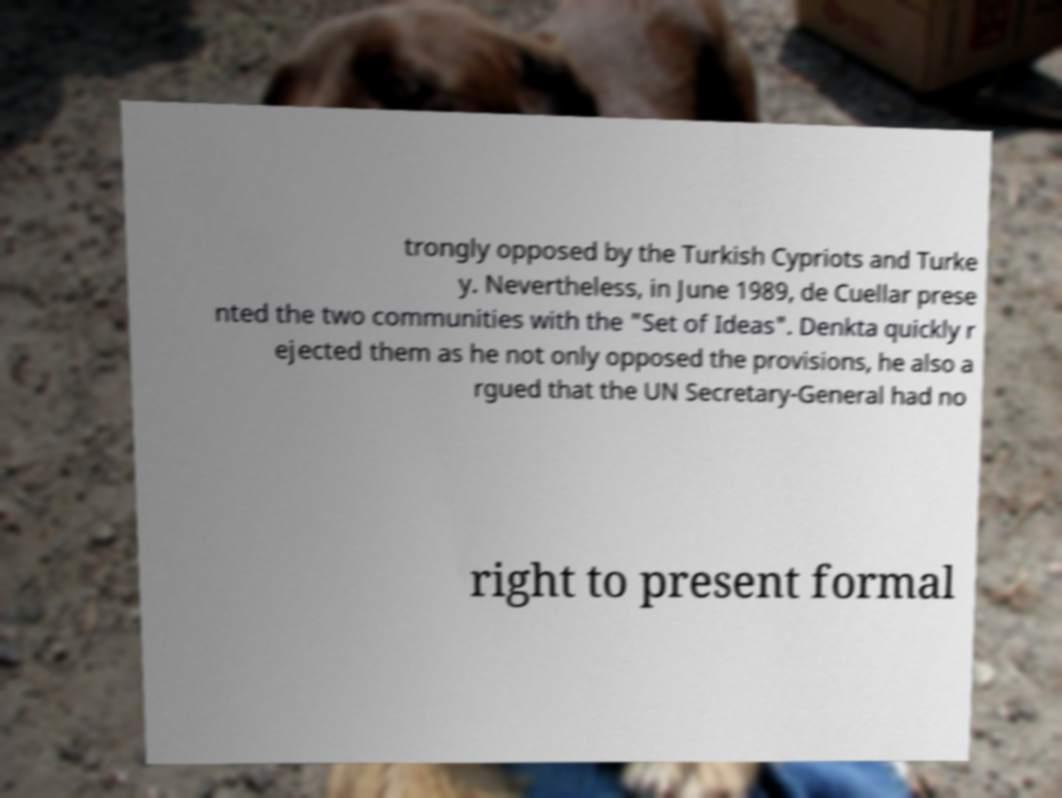What messages or text are displayed in this image? I need them in a readable, typed format. trongly opposed by the Turkish Cypriots and Turke y. Nevertheless, in June 1989, de Cuellar prese nted the two communities with the "Set of Ideas". Denkta quickly r ejected them as he not only opposed the provisions, he also a rgued that the UN Secretary-General had no right to present formal 